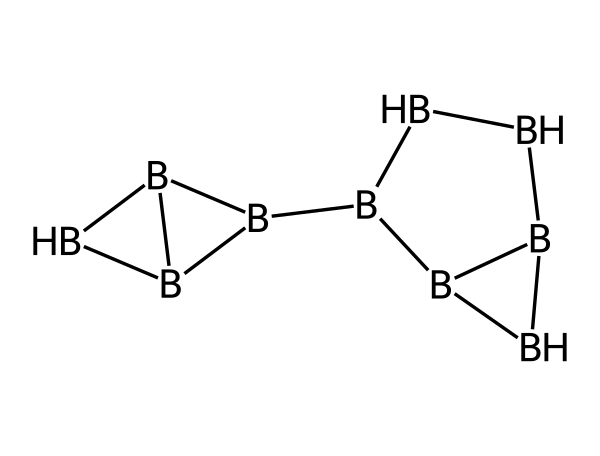What is the chemical name of this compound? The SMILES representation corresponds to a borane compound, specifically pentaborane. This name is derived from the fact that it contains five boron atoms.
Answer: pentaborane How many boron atoms are present in this structure? By examining the SMILES notation, we identify the number of distinct 'B' symbols present, which indicates the number of boron atoms. In this case, there are five 'B' symbols.
Answer: five What is the total number of bonds in the structure? Analyzing the structure, we can count each bond between the boron atoms. Each pair of connected 'B' symbols represents a bond. From the structure, we can see there are seven distinct bonds formed amongst the five boron atoms.
Answer: seven What type of compound is pentaborane classified as? Pentaborane falls under the category of boranes, which are compounds made primarily of boron and hydrogen. This classification is evident from its composition and the presence of boron in the structure.
Answer: borane What is a primary use for pentaborane in space exploration? Pentaborane is considered a potential high-energy propellant, which is useful in rocket propulsion applications due to its high energy density. This application is particularly relevant for space exploration missions.
Answer: propellant How many hydrogen atoms are typically associated with pentaborane? Pentaborane, based on its typical formula, is associated with the presence of ten hydrogen atoms in addition to the five boron atoms, which is necessary for its stability and reactivity.
Answer: ten Which property makes pentaborane potentially useful as a rocket fuel? The high energy density of pentaborane contributes to its efficacy as a rocket fuel. This quality allows it to produce significant thrust, essential for space exploration.
Answer: high energy density 